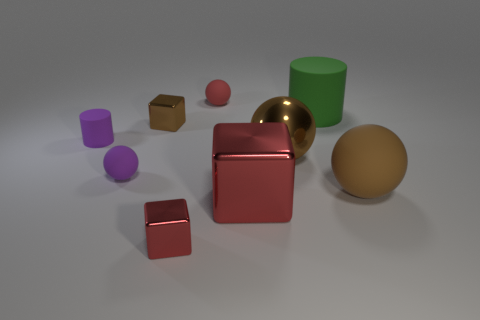What number of tiny things are metal cubes or brown shiny cylinders?
Ensure brevity in your answer.  2. Is the cylinder right of the tiny matte cylinder made of the same material as the red cube that is in front of the big red thing?
Provide a succinct answer. No. What material is the large sphere on the left side of the green matte thing?
Provide a succinct answer. Metal. What number of metal objects are green cylinders or cylinders?
Give a very brief answer. 0. The tiny ball that is in front of the big rubber thing behind the big matte ball is what color?
Provide a short and direct response. Purple. Is the tiny purple cylinder made of the same material as the small ball that is to the left of the small brown metallic block?
Your answer should be compact. Yes. What is the color of the small matte object behind the rubber cylinder on the left side of the small red object behind the tiny red shiny cube?
Your answer should be very brief. Red. Are there any other things that have the same shape as the large green rubber object?
Offer a terse response. Yes. Is the number of big green shiny things greater than the number of purple balls?
Your answer should be very brief. No. How many metal objects are in front of the large brown shiny ball and on the left side of the tiny red rubber sphere?
Keep it short and to the point. 1. 